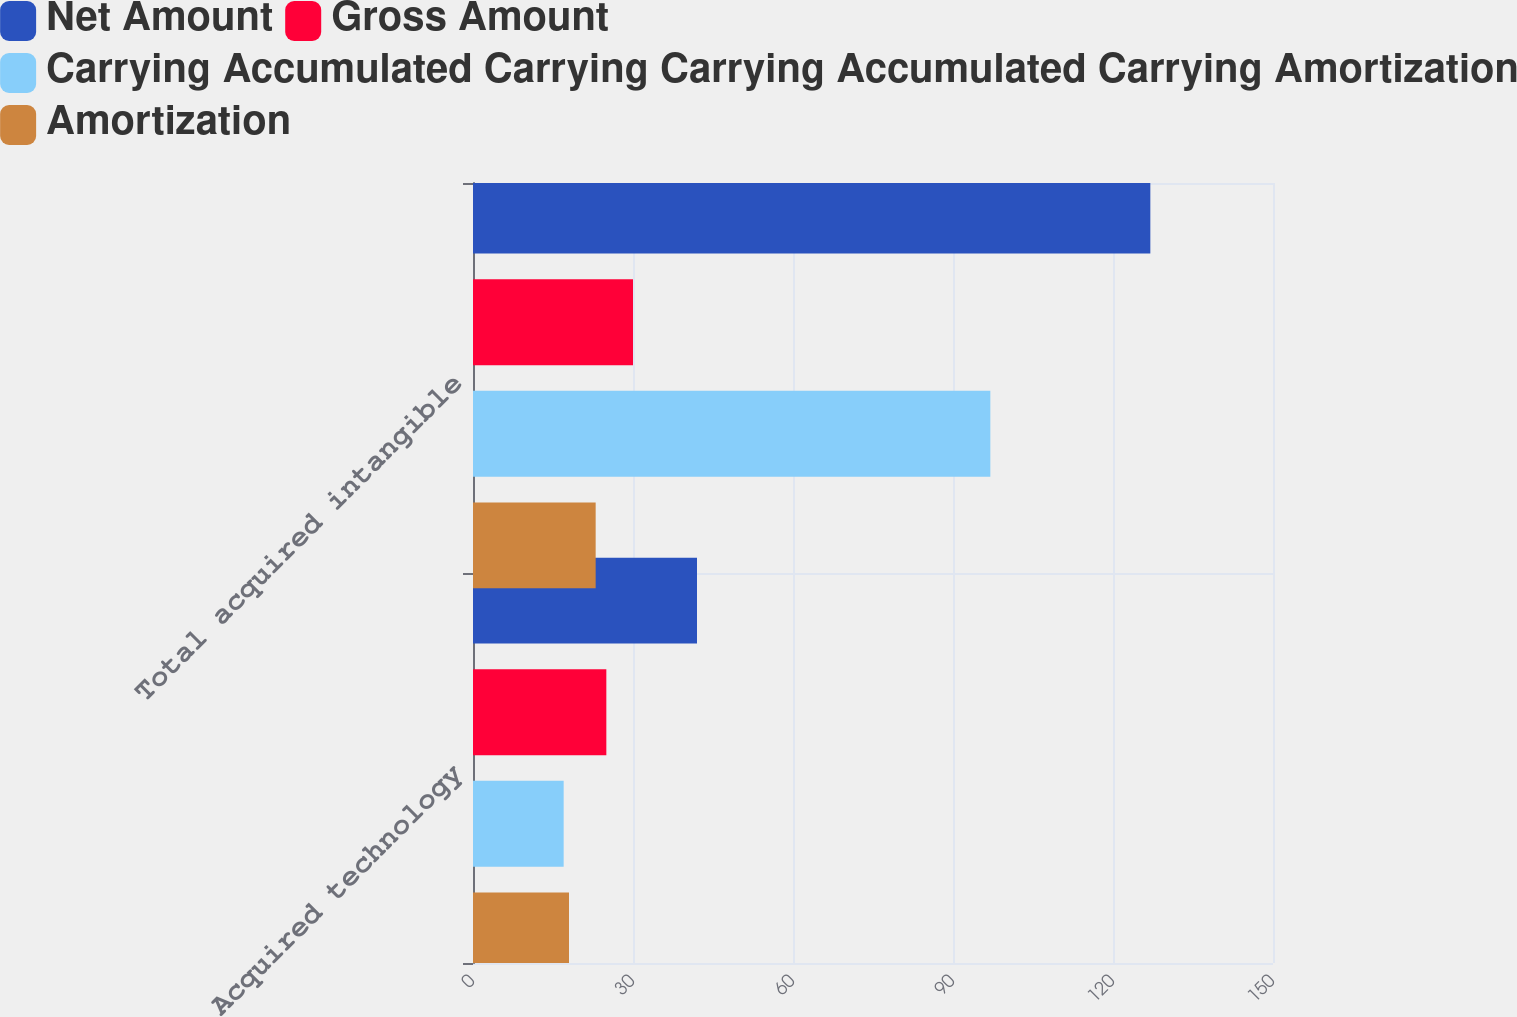Convert chart. <chart><loc_0><loc_0><loc_500><loc_500><stacked_bar_chart><ecel><fcel>Acquired technology<fcel>Total acquired intangible<nl><fcel>Net Amount<fcel>42<fcel>127<nl><fcel>Gross Amount<fcel>25<fcel>30<nl><fcel>Carrying Accumulated Carrying Carrying Accumulated Carrying Amortization<fcel>17<fcel>97<nl><fcel>Amortization<fcel>18<fcel>23<nl></chart> 